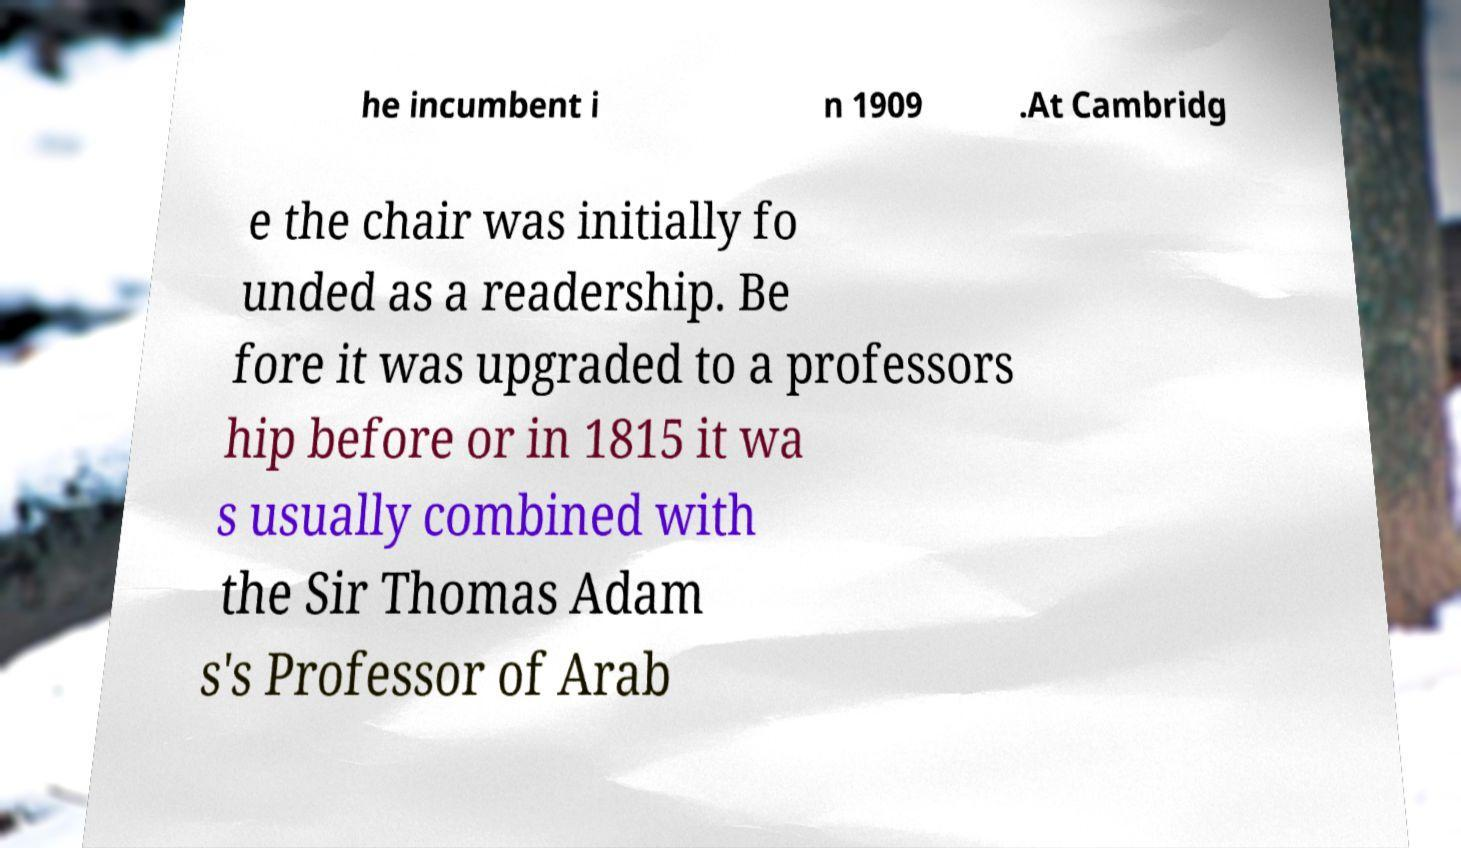For documentation purposes, I need the text within this image transcribed. Could you provide that? he incumbent i n 1909 .At Cambridg e the chair was initially fo unded as a readership. Be fore it was upgraded to a professors hip before or in 1815 it wa s usually combined with the Sir Thomas Adam s's Professor of Arab 